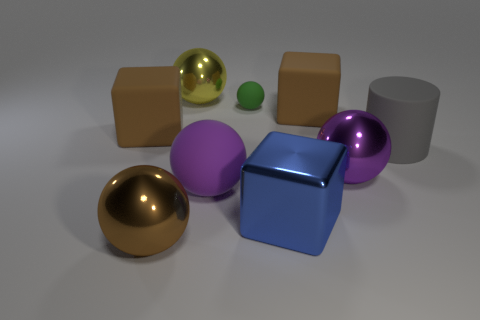Is the big metal block the same color as the big matte ball?
Provide a succinct answer. No. There is a rubber sphere behind the large matte ball; is its color the same as the shiny cube?
Provide a succinct answer. No. Are there any other objects that have the same shape as the big gray thing?
Your answer should be compact. No. What is the color of the rubber ball that is the same size as the gray rubber cylinder?
Make the answer very short. Purple. What is the size of the metallic sphere that is behind the gray object?
Give a very brief answer. Large. Are there any metallic spheres that are on the right side of the big brown rubber block that is right of the small green ball?
Provide a succinct answer. Yes. Does the block that is in front of the large gray cylinder have the same material as the green ball?
Ensure brevity in your answer.  No. What number of brown things are on the right side of the large purple rubber thing and in front of the blue block?
Make the answer very short. 0. How many small green spheres have the same material as the yellow thing?
Offer a very short reply. 0. The large cube that is made of the same material as the yellow thing is what color?
Your response must be concise. Blue. 